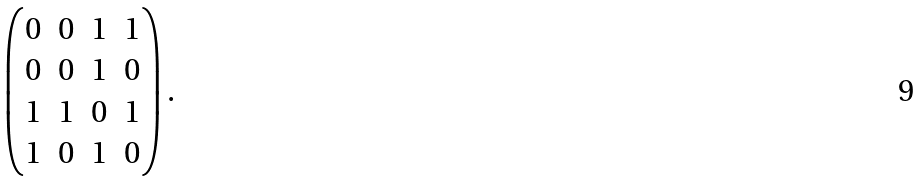Convert formula to latex. <formula><loc_0><loc_0><loc_500><loc_500>\begin{pmatrix} 0 & 0 & 1 & 1 \\ 0 & 0 & 1 & 0 \\ 1 & 1 & 0 & 1 \\ 1 & 0 & 1 & 0 \end{pmatrix} .</formula> 